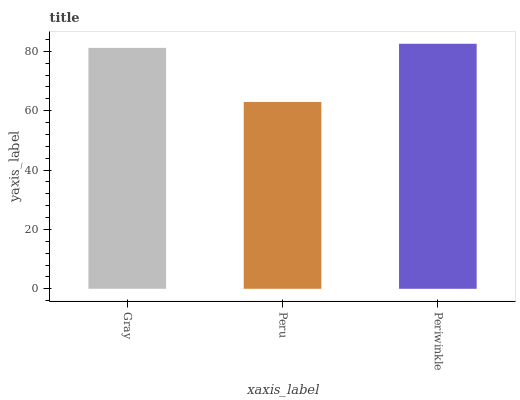Is Peru the minimum?
Answer yes or no. Yes. Is Periwinkle the maximum?
Answer yes or no. Yes. Is Periwinkle the minimum?
Answer yes or no. No. Is Peru the maximum?
Answer yes or no. No. Is Periwinkle greater than Peru?
Answer yes or no. Yes. Is Peru less than Periwinkle?
Answer yes or no. Yes. Is Peru greater than Periwinkle?
Answer yes or no. No. Is Periwinkle less than Peru?
Answer yes or no. No. Is Gray the high median?
Answer yes or no. Yes. Is Gray the low median?
Answer yes or no. Yes. Is Periwinkle the high median?
Answer yes or no. No. Is Peru the low median?
Answer yes or no. No. 